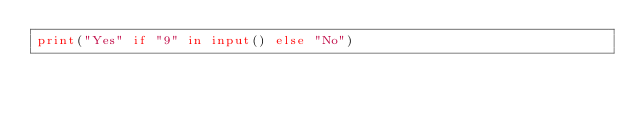Convert code to text. <code><loc_0><loc_0><loc_500><loc_500><_Python_>print("Yes" if "9" in input() else "No")</code> 